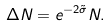Convert formula to latex. <formula><loc_0><loc_0><loc_500><loc_500>\Delta N = e ^ { - 2 \tilde { \sigma } } N .</formula> 